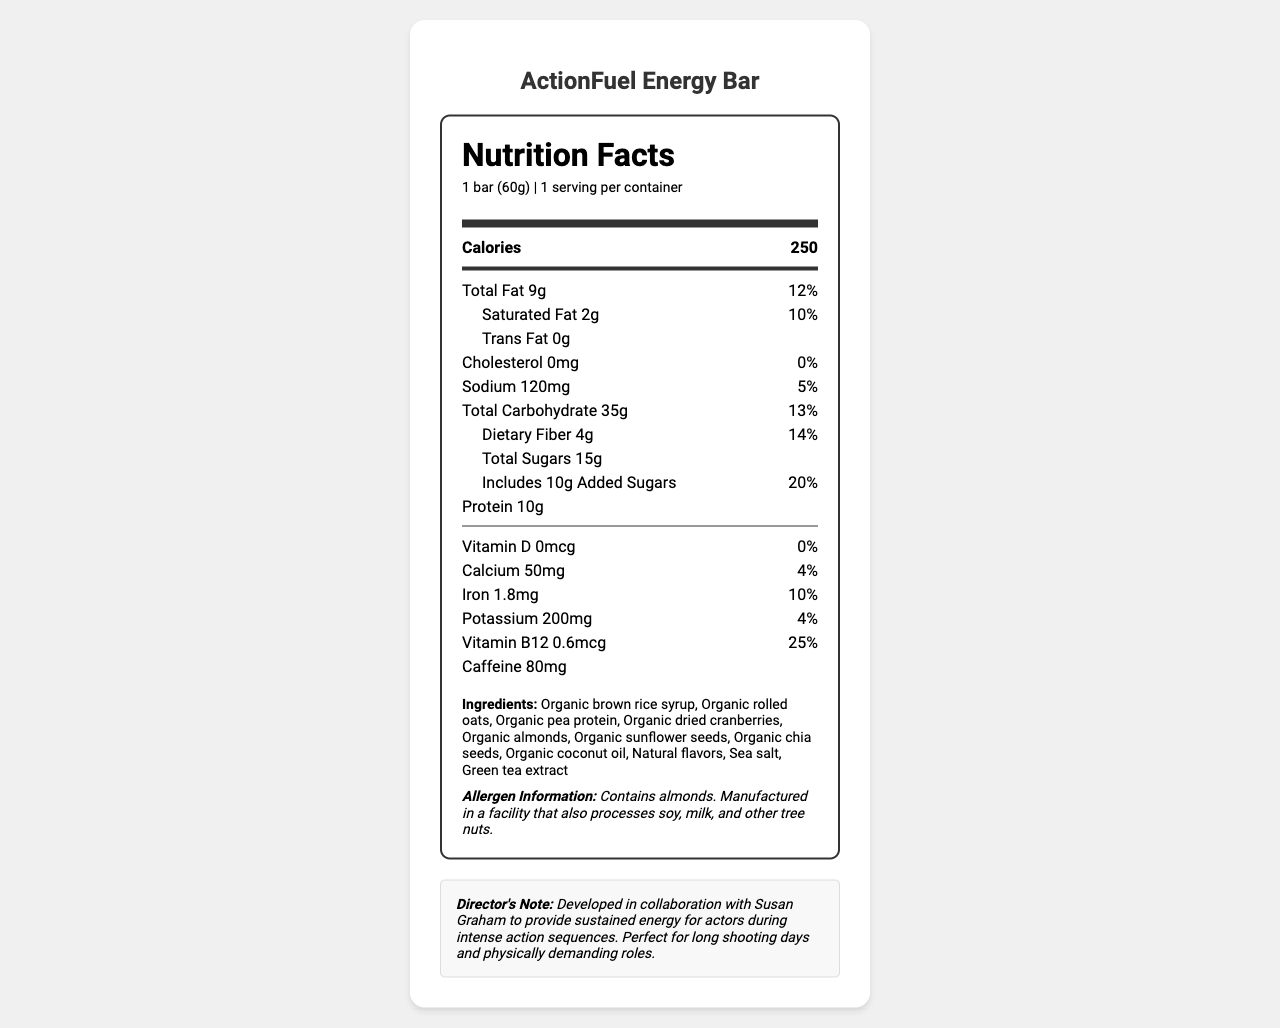what is the serving size for the ActionFuel Energy Bar? The document states that the serving size is "1 bar (60g)" under the serving information section.
Answer: 1 bar (60g) how many grams of protein does one ActionFuel Energy Bar contain? The nutrition label indicates that each bar contains 10g of protein.
Answer: 10g what is the daily value percentage for dietary fiber in the ActionFuel Energy Bar? According to the label, the daily value percentage for dietary fiber is 14%.
Answer: 14% list three ingredients found in the ActionFuel Energy Bar. The ingredient list includes these items among others.
Answer: Organic brown rice syrup, Organic rolled oats, Organic pea protein does the ActionFuel Energy Bar contain any trans fat? The document specifies that the trans fat amount is "0g."
Answer: No what is the amount of caffeine in the ActionFuel Energy Bar? The caffeine amount listed is "80mg."
Answer: 80mg what vitamins and minerals are present in the ActionFuel Energy Bar, and what are their daily values? The nutrition label states the daily values for these nutrients.
Answer: Vitamin D (0%), Calcium (4%), Iron (10%), Potassium (4%), Vitamin B12 (25%) how much sodium does the ActionFuel Energy Bar have? A. 100mg B. 120mg C. 150mg D. 200mg The document specifies that the sodium content is "120mg."
Answer: B. 120mg what percentage of the daily value for saturated fat does the ActionFuel Energy Bar contain? A. 5% B. 10% C. 15% D. 20% The nutrition label shows that the daily value for saturated fat is 10%.
Answer: B. 10% are there any allergens to be aware of in the ActionFuel Energy Bar? The allergen information states that it contains almonds and is manufactured in a facility that processes soy, milk, and other tree nuts.
Answer: Yes is the ActionFuel Energy Bar suitable for someone who is allergic to soy? The allergen information indicates that the product is manufactured in a facility that also processes soy.
Answer: No summarize the main idea of the document. The document gives a detailed overview of the energy bar's nutritional content and its purpose in supporting high-energy activities for actors, referencing a collaboration with Susan Graham.
Answer: The document provides the nutrition facts for the ActionFuel Energy Bar, including calorie content, macronutrients, vitamins, minerals, ingredients, and allergen information. It highlights that the bar is designed to provide sustained energy for actors during intense action sequences. what is the total weight of one serving of the ActionFuel Energy Bar? The serving size is specified as "1 bar (60g)" in the nutrition facts.
Answer: 60g is there any cholesterol in the ActionFuel Energy Bar? The document shows "0mg" of cholesterol, indicating it contains no cholesterol.
Answer: No how many servings per container are there for the ActionFuel Energy Bar? A. 1 B. 2 C. 3 D. 4 The document indicates that there is "1 serving per container."
Answer: A. 1 what is the source of the green tea extract in the ActionFuel Energy Bar? The document lists "green tea extract" as an ingredient but does not provide information about its source.
Answer: Cannot be determined what is the note from the director about the ActionFuel Energy Bar? This note is included at the end of the document and provides the context for the bar's development and intended use case.
Answer: Developed in collaboration with Susan Graham to provide sustained energy for actors during intense action sequences. Perfect for long shooting days and physically demanding roles. 